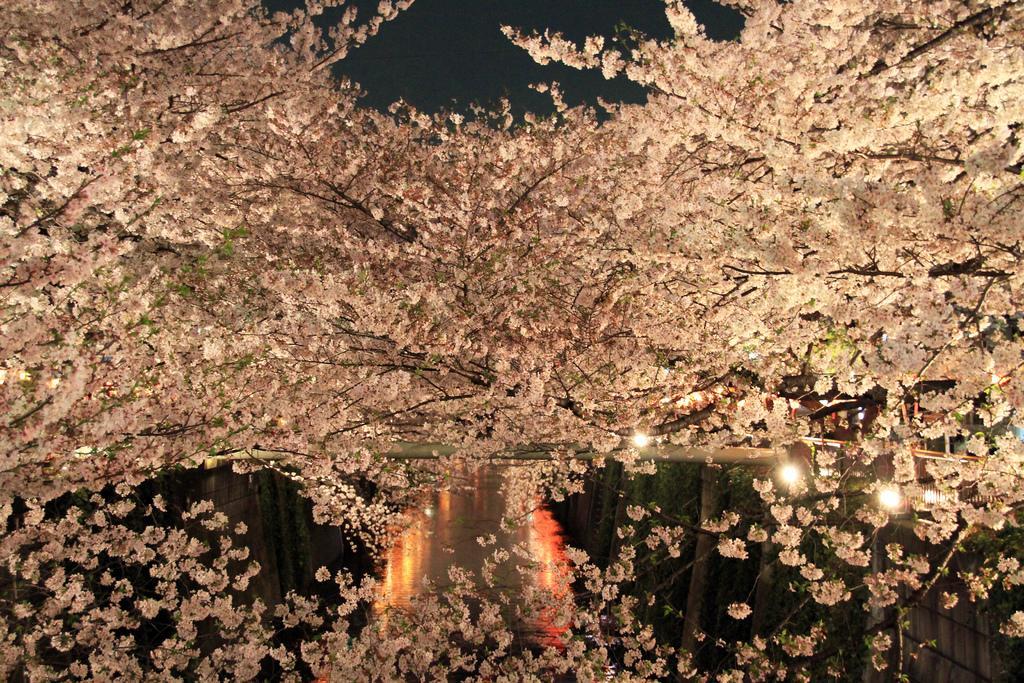In one or two sentences, can you explain what this image depicts? In this image I can see many trees and the lights. I can see there is a black background. 